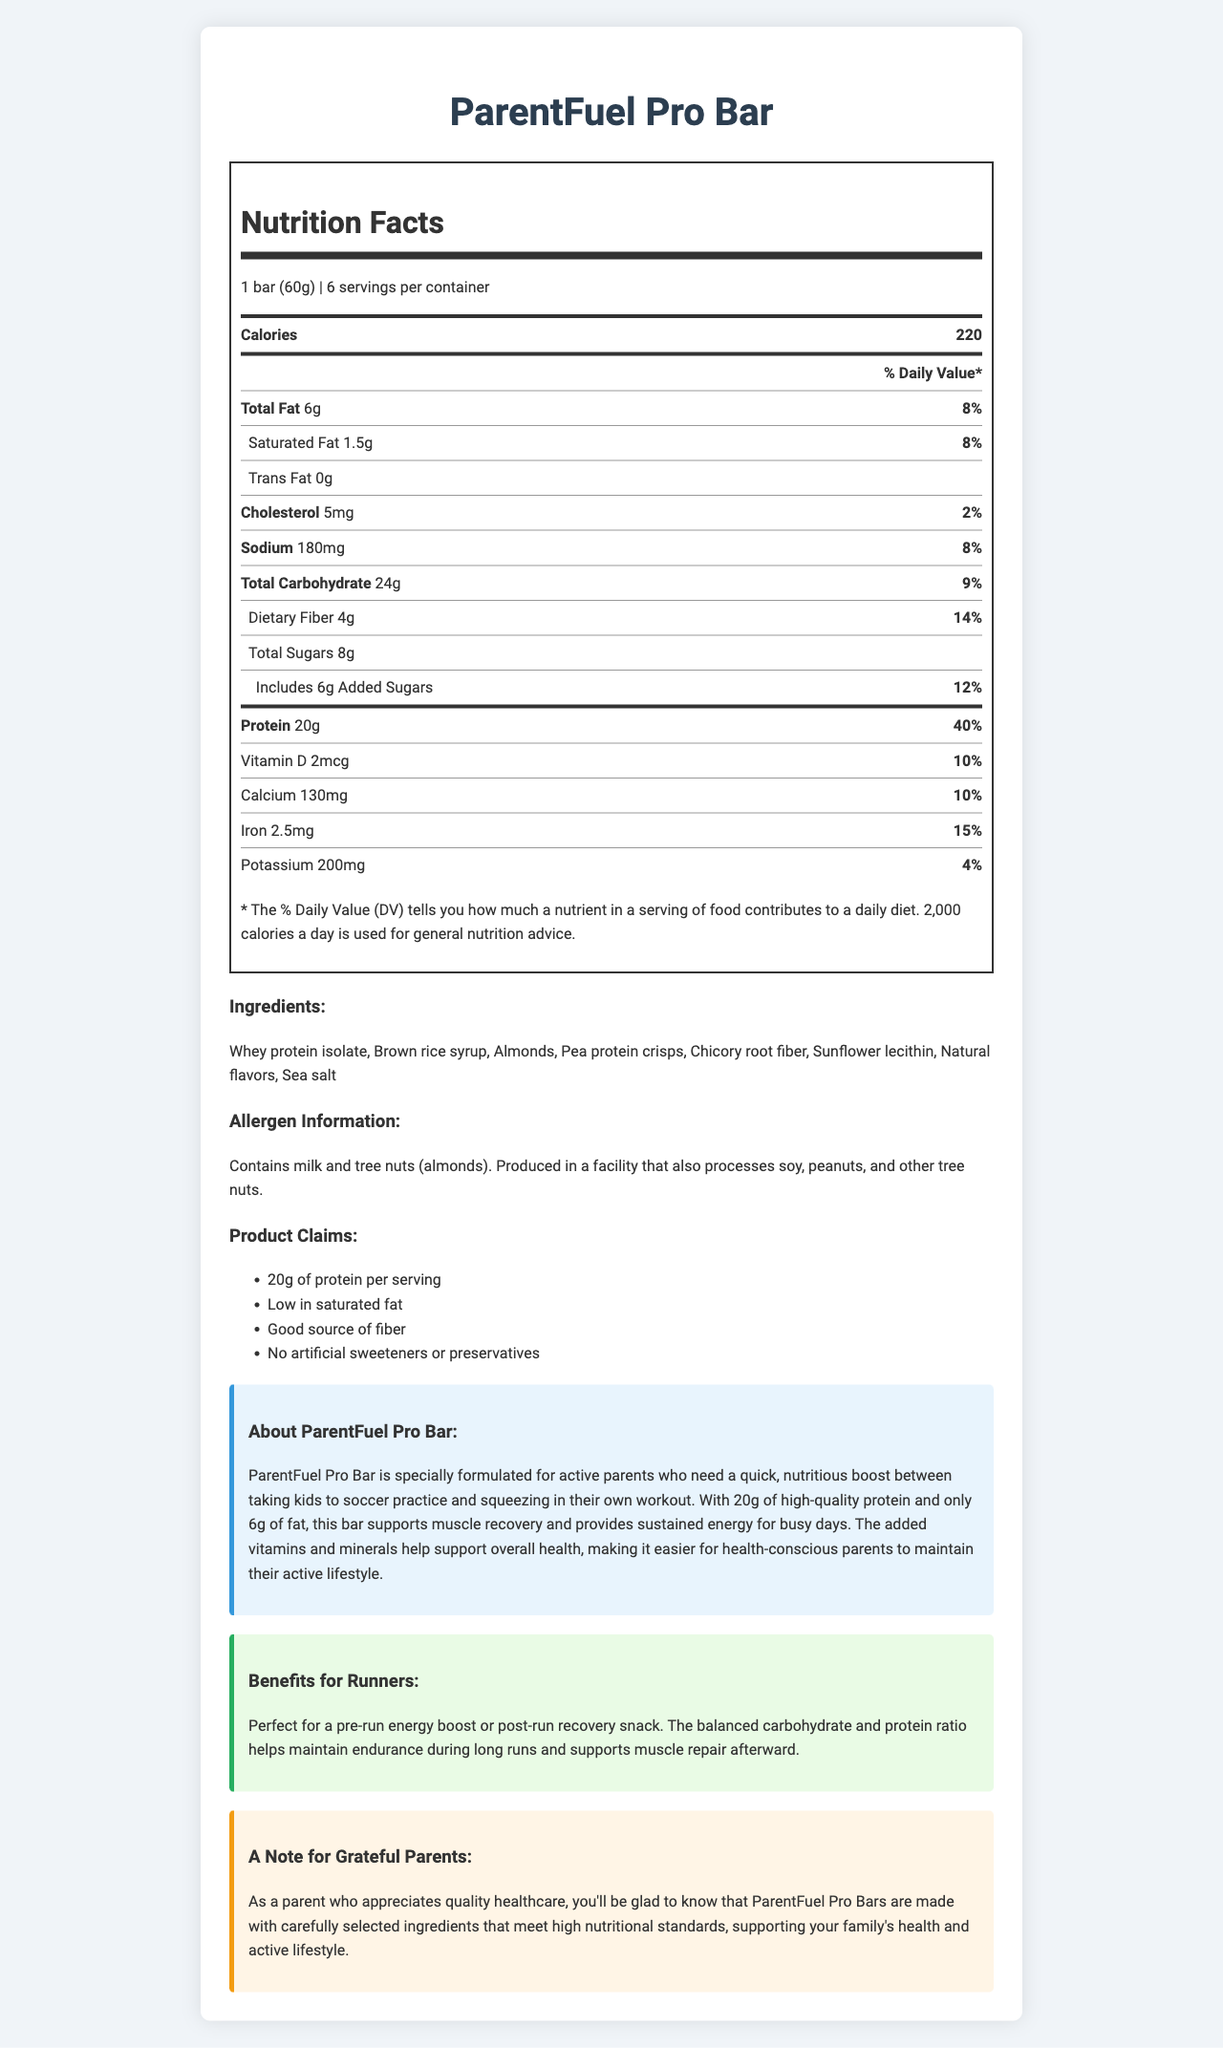what is the serving size of the ParentFuel Pro Bar? The serving size is listed at the top of the Nutrition Facts section, indicating it is "1 bar (60g)".
Answer: 1 bar (60g) how many calories are in each serving? According to the Nutrition Facts, each serving contains 220 calories.
Answer: 220 how much protein is in one ParentFuel Pro Bar? The Nutrition Facts state that each bar contains 20g of protein.
Answer: 20g what percentage of the daily value does the dietary fiber content represent? The dietary fiber content is listed as 4g, which is 14% of the daily value.
Answer: 14% which allergens are present in the ParentFuel Pro Bar? The allergen information section specifies that the bar contains milk and tree nuts (almonds).
Answer: Contains milk and tree nuts (almonds) how many servings are there in a container of ParentFuel Pro Bar? The Nutrition Facts specify there are 6 servings per container.
Answer: 6 what is the total fat content in one serving? The Nutrition Facts list the total fat content as 6g per serving.
Answer: 6g how much potassium does one serving contain? The Nutrition Facts indicate that one serving contains 200mg of potassium.
Answer: 200mg what is the main source of protein in the ParentFuel Pro Bar? A. Almonds B. Whey protein isolate C. Pea protein crisps D. Brown rice syrup The ingredients list shows that whey protein isolate is mentioned first, indicating it is the main source of protein.
Answer: B. Whey protein isolate what is the percentage daily value of calcium per serving? The Nutrition Facts show that each serving provides 10% of the daily value of calcium.
Answer: 10% how many dietary fibers are in one serving? A. 3g B. 4g C. 5g D. 6g The dietary fiber content is listed as 4g per serving in the Nutrition Facts.
Answer: B. 4g which claim is made about the ParentFuel Pro Bar? A. 10g of protein per serving B. High in saturated fat C. Contains artificial sweeteners D. Good source of fiber The claim statements include that the bar is a "Good source of fiber".
Answer: D. Good source of fiber do ParentFuel Pro Bars contain artificial sweeteners? The claim statements specifically note that there are "No artificial sweeteners or preservatives".
Answer: No what is the primary purpose of the ParentFuel Pro Bar according to the document? The marketing description highlights that the bar is specially formulated for active parents to support muscle recovery and provide sustained energy.
Answer: To provide a nutritious boost for active parents and support muscle recovery and sustained energy. list the four main health benefit claims made for the ParentFuel Pro Bar? The claims section lists these four health benefits.
Answer: 20g of protein per serving, Low in saturated fat, Good source of fiber, No artificial sweeteners or preservatives what ingredients are used in the ParentFuel Pro Bar? The ingredients section lists all the ingredients used in the bar.
Answer: Whey protein isolate, Brown rice syrup, Almonds, Pea protein crisps, Chicory root fiber, Sunflower lecithin, Natural flavors, Sea salt how much cholesterol is in each serving? According to the Nutrition Facts, each serving contains 5mg of cholesterol.
Answer: 5mg what is the purpose of the ParentFuel Pro Bar for runners? The benefits for runners section describes the bar's purpose for runners.
Answer: To provide a pre-run energy boost or post-run recovery snack, helping maintain endurance and support muscle repair. describe the overall focus of the document? The document comprehensively lists the nutritional and health benefits, ingredients, claims, and specific notes to its target consumers, active parents and runners.
Answer: The document provides detailed nutritional information, ingredient lists, allergen information, and marketing highlights of the ParentFuel Pro Bar designed for active parents. It emphasizes the bar's high protein content, low fat, additional health benefits, and suitability for runners, along with a note of gratitude for parents who value health care. what is the exact percentage daily value of proteins in the ParentFuel Pro Bar? The Nutrition Facts state that the protein content represents 40% of the daily value.
Answer: 40% is the amount of added sugars more than the total sugars? The Nutrition Facts indicate that added sugars are 6g out of the total 8g sugars, so it cannot be more than the total sugars. The added sugars are not more than the total sugars.
Answer: Not enough information 